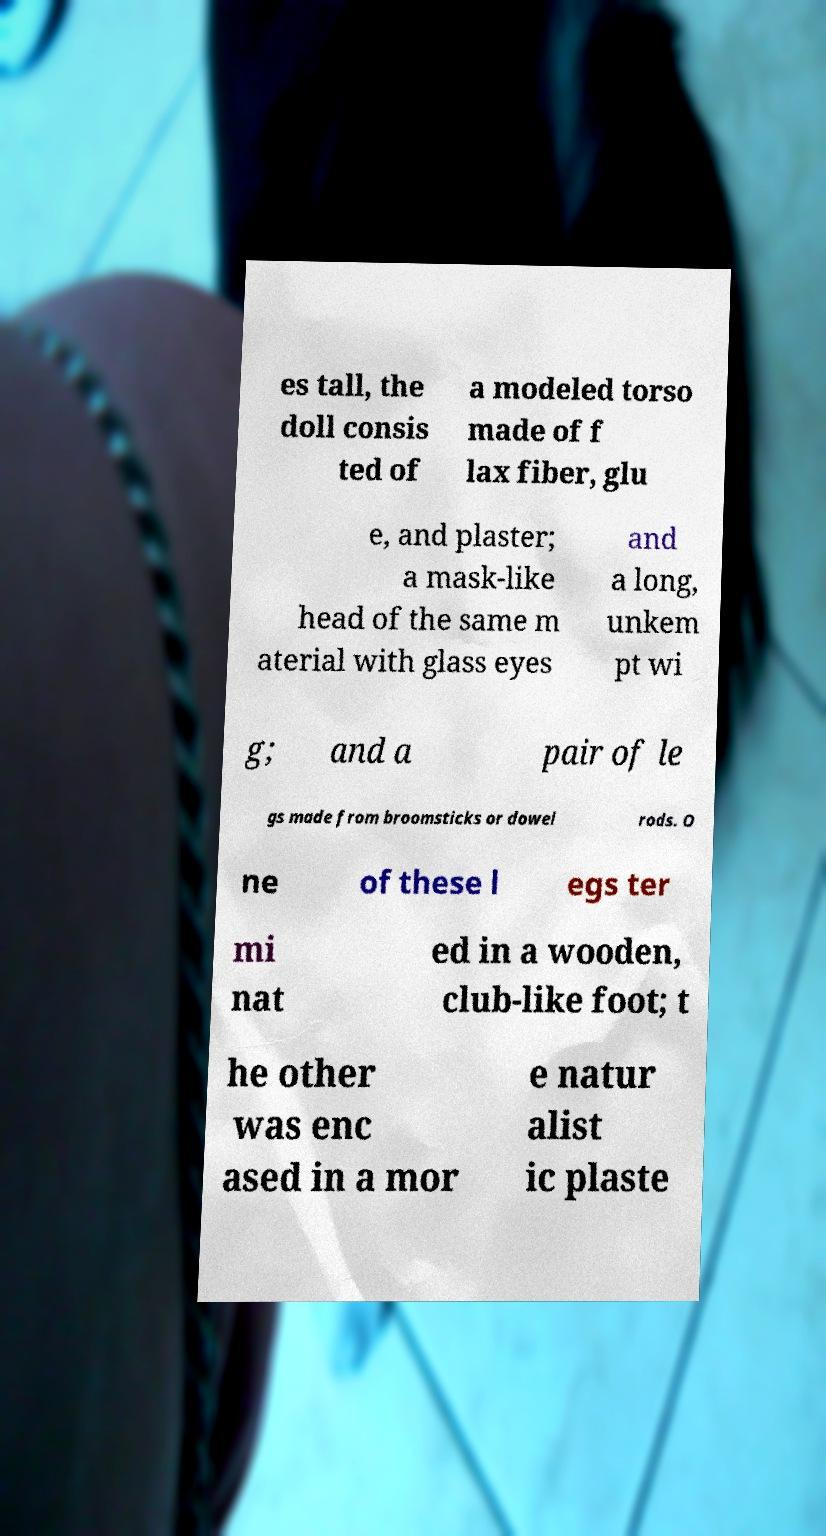Can you read and provide the text displayed in the image?This photo seems to have some interesting text. Can you extract and type it out for me? es tall, the doll consis ted of a modeled torso made of f lax fiber, glu e, and plaster; a mask-like head of the same m aterial with glass eyes and a long, unkem pt wi g; and a pair of le gs made from broomsticks or dowel rods. O ne of these l egs ter mi nat ed in a wooden, club-like foot; t he other was enc ased in a mor e natur alist ic plaste 